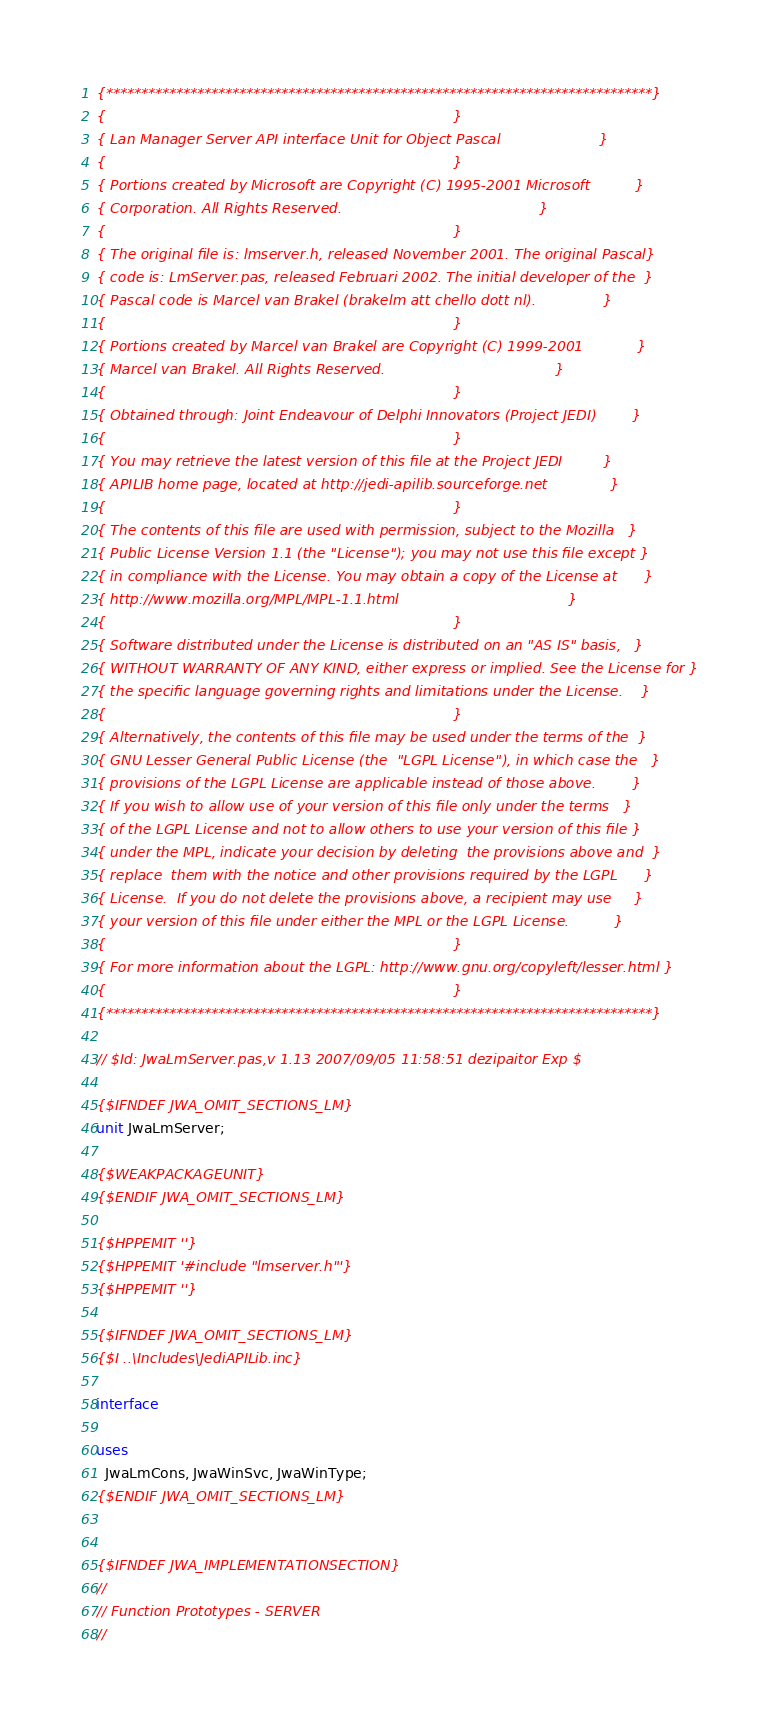Convert code to text. <code><loc_0><loc_0><loc_500><loc_500><_Pascal_>{******************************************************************************}
{                                                                              }
{ Lan Manager Server API interface Unit for Object Pascal                      }
{                                                                              }
{ Portions created by Microsoft are Copyright (C) 1995-2001 Microsoft          }
{ Corporation. All Rights Reserved.                                            }
{                                                                              }
{ The original file is: lmserver.h, released November 2001. The original Pascal}
{ code is: LmServer.pas, released Februari 2002. The initial developer of the  }
{ Pascal code is Marcel van Brakel (brakelm att chello dott nl).               }
{                                                                              }
{ Portions created by Marcel van Brakel are Copyright (C) 1999-2001            }
{ Marcel van Brakel. All Rights Reserved.                                      }
{                                                                              }
{ Obtained through: Joint Endeavour of Delphi Innovators (Project JEDI)        }
{                                                                              }
{ You may retrieve the latest version of this file at the Project JEDI         }
{ APILIB home page, located at http://jedi-apilib.sourceforge.net              }
{                                                                              }
{ The contents of this file are used with permission, subject to the Mozilla   }
{ Public License Version 1.1 (the "License"); you may not use this file except }
{ in compliance with the License. You may obtain a copy of the License at      }
{ http://www.mozilla.org/MPL/MPL-1.1.html                                      }
{                                                                              }
{ Software distributed under the License is distributed on an "AS IS" basis,   }
{ WITHOUT WARRANTY OF ANY KIND, either express or implied. See the License for }
{ the specific language governing rights and limitations under the License.    }
{                                                                              }
{ Alternatively, the contents of this file may be used under the terms of the  }
{ GNU Lesser General Public License (the  "LGPL License"), in which case the   }
{ provisions of the LGPL License are applicable instead of those above.        }
{ If you wish to allow use of your version of this file only under the terms   }
{ of the LGPL License and not to allow others to use your version of this file }
{ under the MPL, indicate your decision by deleting  the provisions above and  }
{ replace  them with the notice and other provisions required by the LGPL      }
{ License.  If you do not delete the provisions above, a recipient may use     }
{ your version of this file under either the MPL or the LGPL License.          }
{                                                                              }
{ For more information about the LGPL: http://www.gnu.org/copyleft/lesser.html }
{                                                                              }
{******************************************************************************}

// $Id: JwaLmServer.pas,v 1.13 2007/09/05 11:58:51 dezipaitor Exp $

{$IFNDEF JWA_OMIT_SECTIONS_LM}
unit JwaLmServer;

{$WEAKPACKAGEUNIT}
{$ENDIF JWA_OMIT_SECTIONS_LM}

{$HPPEMIT ''}
{$HPPEMIT '#include "lmserver.h"'}
{$HPPEMIT ''}

{$IFNDEF JWA_OMIT_SECTIONS_LM}
{$I ..\Includes\JediAPILib.inc}

interface

uses
  JwaLmCons, JwaWinSvc, JwaWinType;
{$ENDIF JWA_OMIT_SECTIONS_LM}


{$IFNDEF JWA_IMPLEMENTATIONSECTION}
//
// Function Prototypes - SERVER
//
</code> 